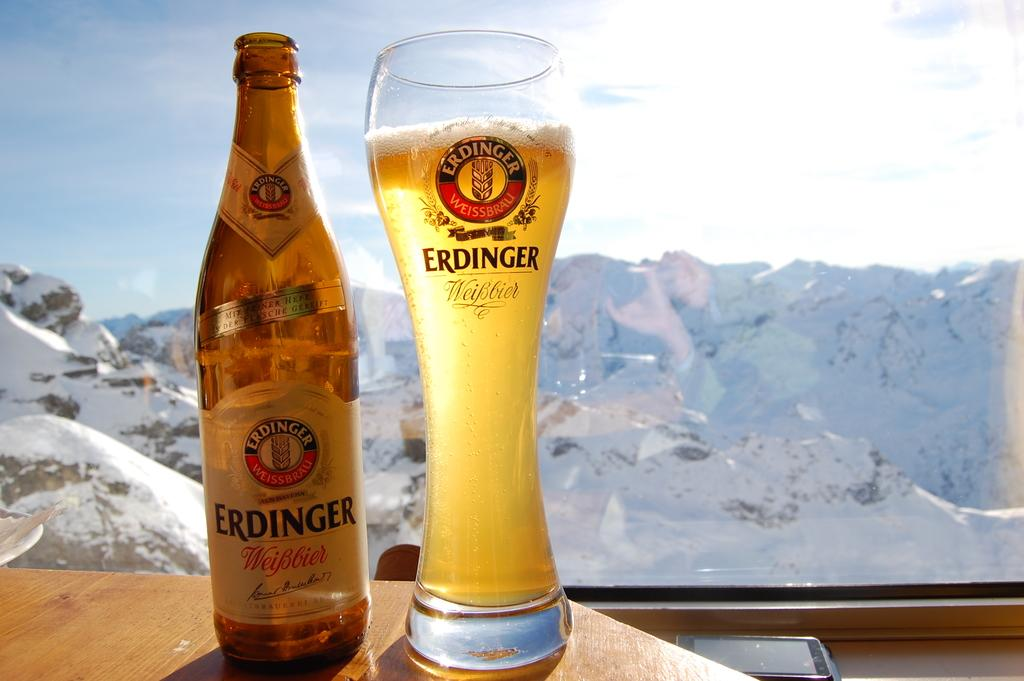Provide a one-sentence caption for the provided image. Bottle of Erdinger and a glass stands next to it in a window. 